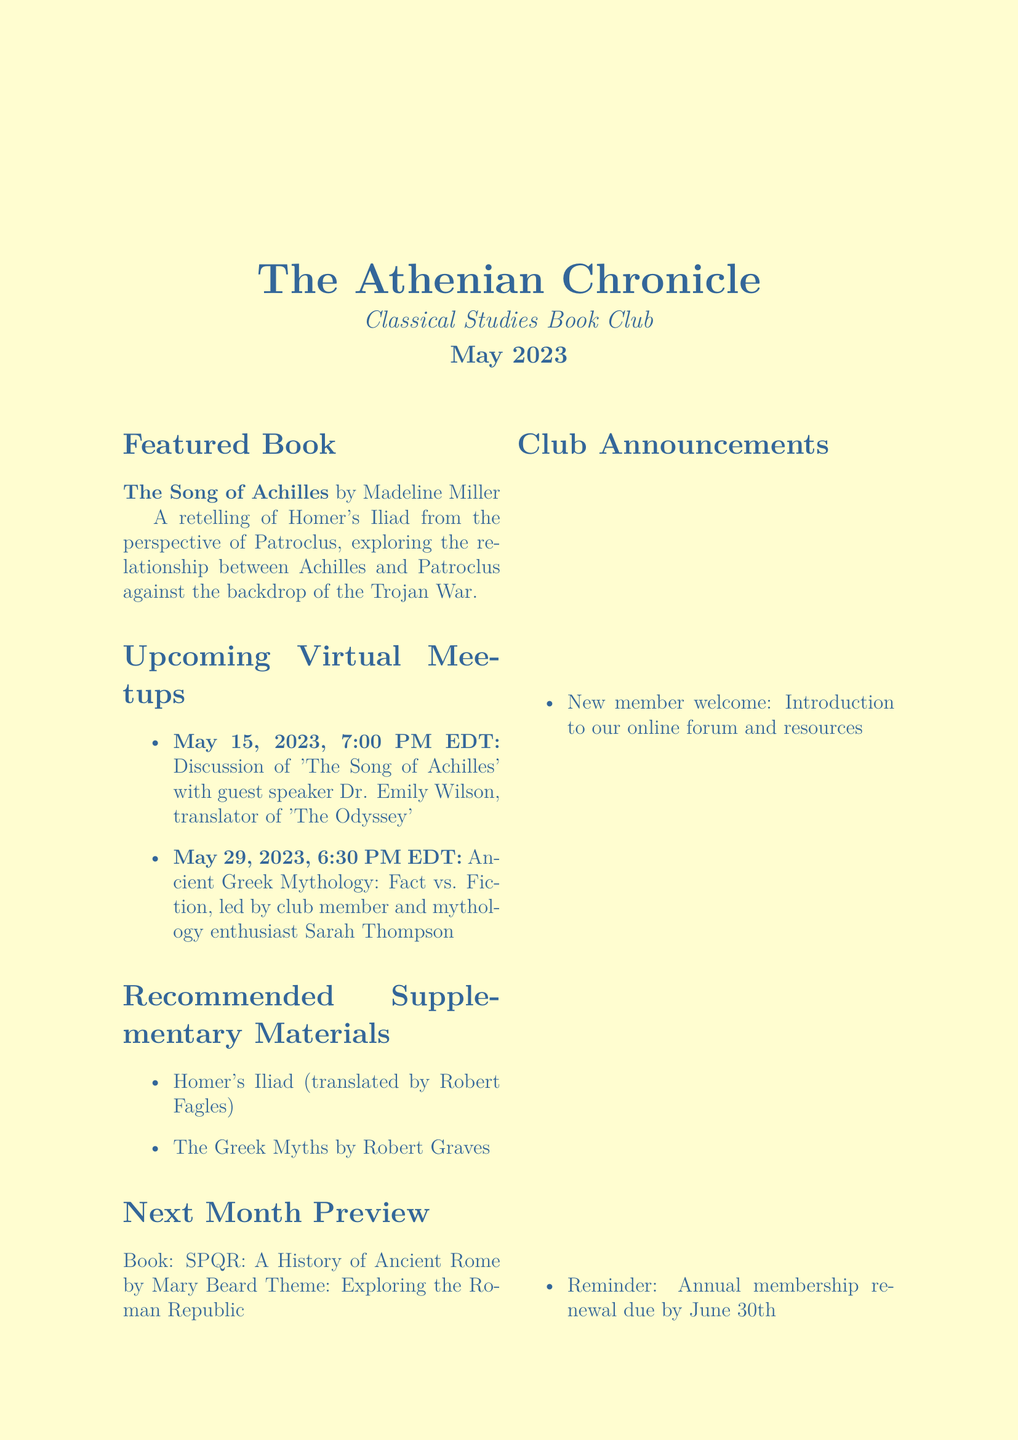What is the title of the featured book? The title of the featured book is clearly stated in the document as part of its structure.
Answer: The Song of Achilles Who is the author of the featured book? The author's name is provided in the featured book section of the newsletter.
Answer: Madeline Miller What is the date and time of the first virtual meetup? The exact information for the first meetup is listed in the upcoming virtual meetups section.
Answer: May 15, 2023, 7:00 PM EDT Who is the guest speaker for the first virtual meetup? The document mentions the guest speaker directly associated with the first meetup topic.
Answer: Dr. Emily Wilson What is the theme of next month's book selection? The theme for next month’s reading is stated in the preview section of the newsletter.
Answer: Exploring the Roman Republic What is one of the recommended supplementary materials? Recommended supplementary materials are listed clearly in the document, allowing for easy retrieval.
Answer: Homer's Iliad (translated by Robert Fagles) What is the deadline for annual membership renewal? The membership renewal deadline is specified in club announcements, making it easy to locate.
Answer: June 30th What genre does "The Song of Achilles" fall under? The description of the book in the newsletter suggests its genre based on its content and context.
Answer: Fiction 